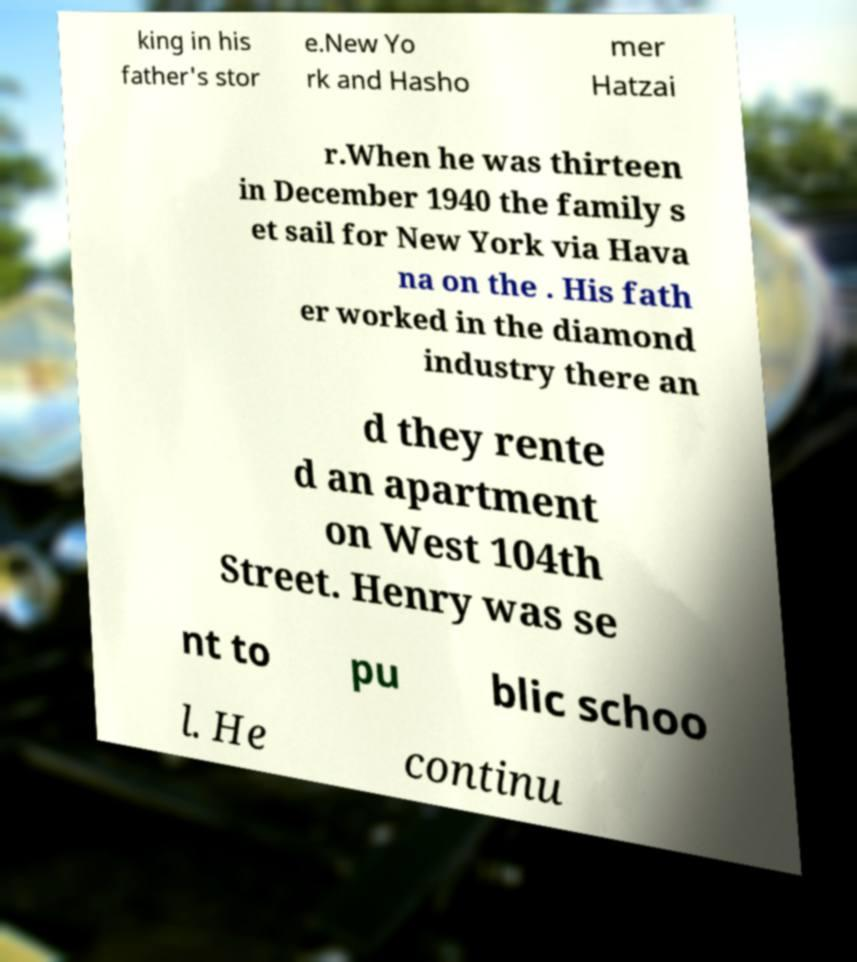Could you assist in decoding the text presented in this image and type it out clearly? king in his father's stor e.New Yo rk and Hasho mer Hatzai r.When he was thirteen in December 1940 the family s et sail for New York via Hava na on the . His fath er worked in the diamond industry there an d they rente d an apartment on West 104th Street. Henry was se nt to pu blic schoo l. He continu 